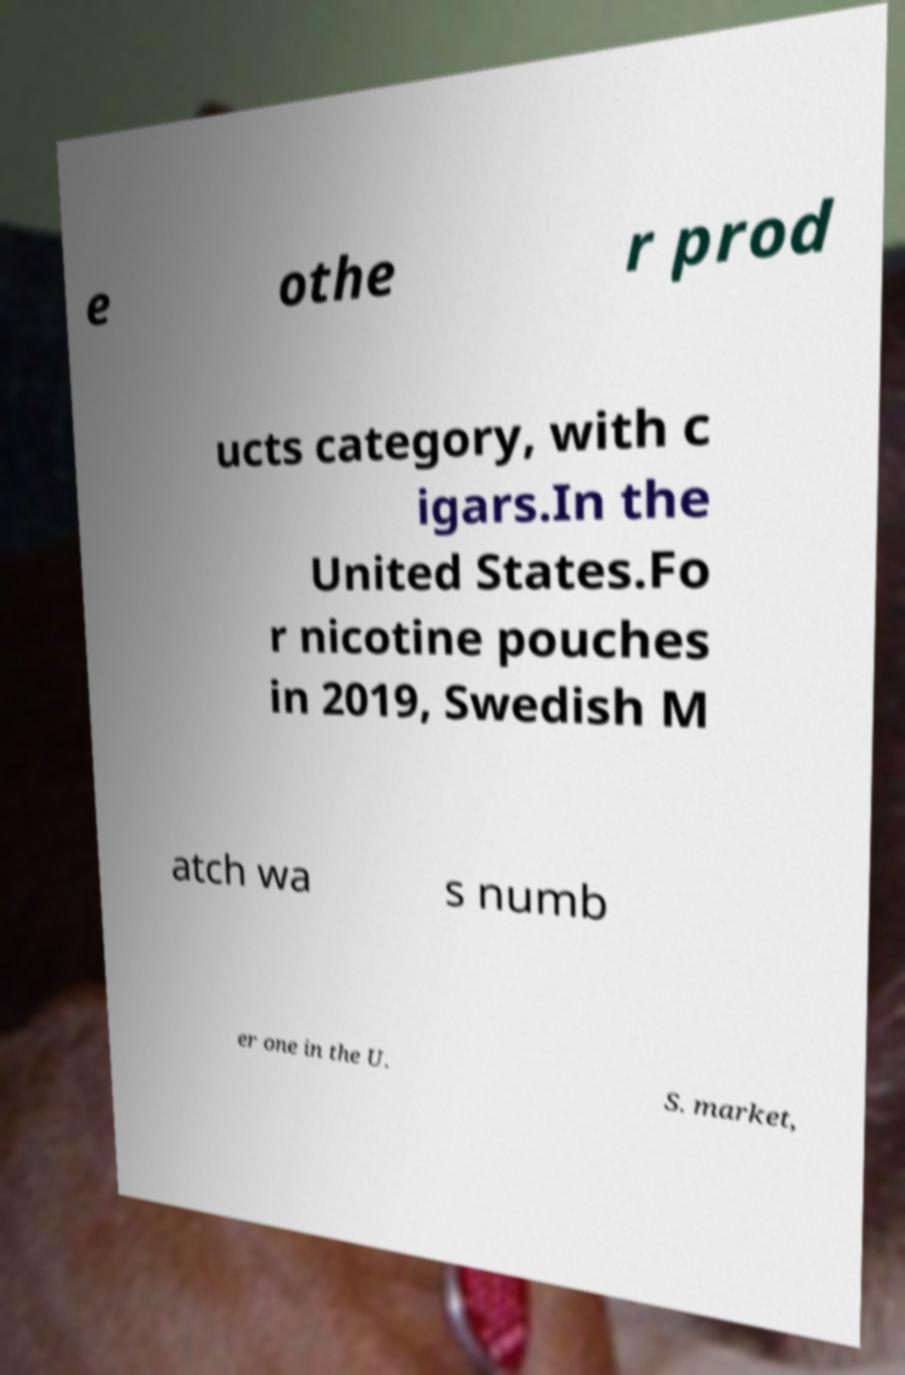Please read and relay the text visible in this image. What does it say? e othe r prod ucts category, with c igars.In the United States.Fo r nicotine pouches in 2019, Swedish M atch wa s numb er one in the U. S. market, 